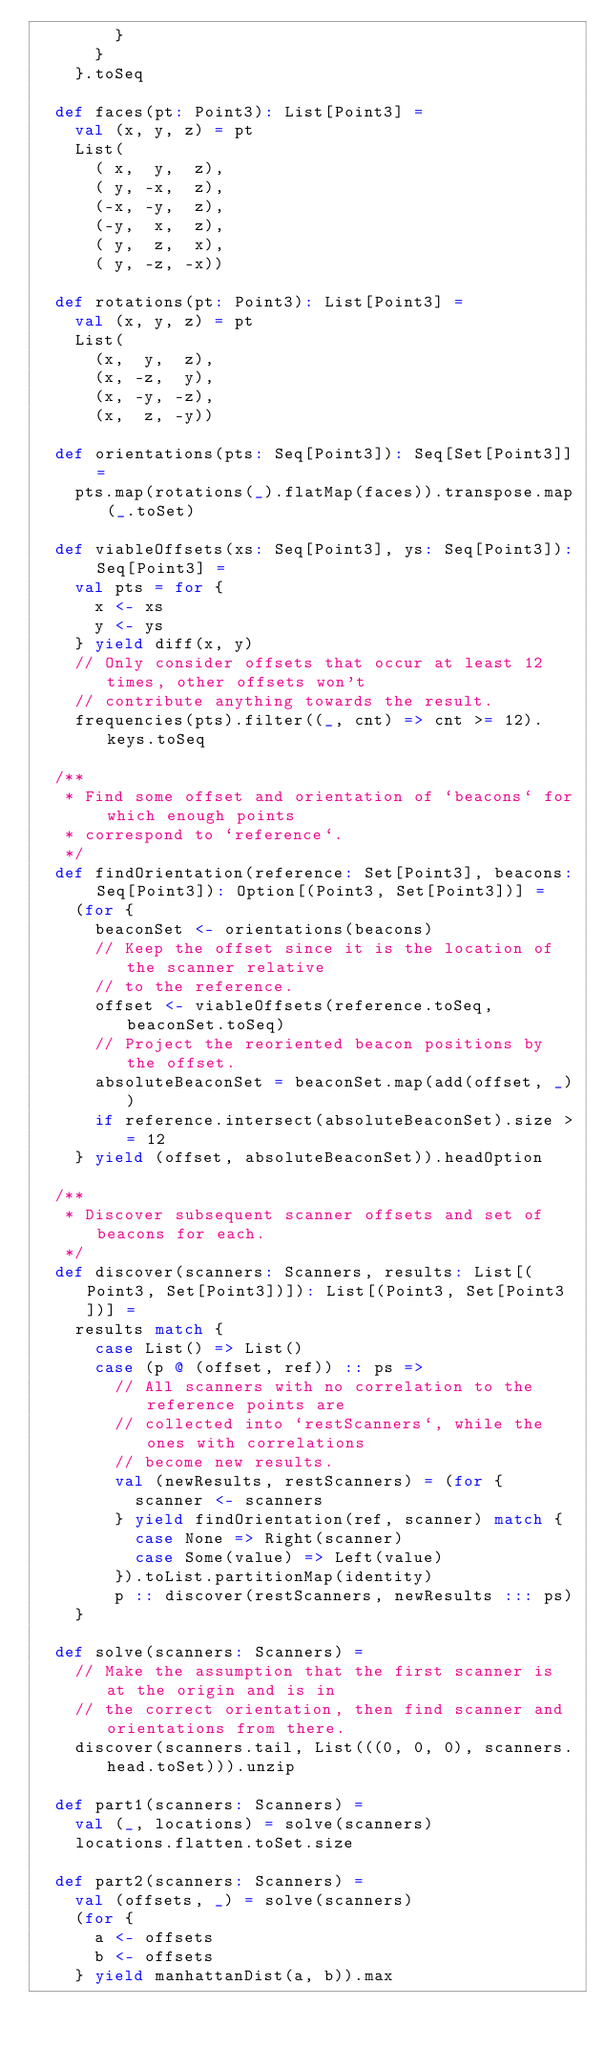<code> <loc_0><loc_0><loc_500><loc_500><_Scala_>        }
      }
    }.toSeq

  def faces(pt: Point3): List[Point3] =
    val (x, y, z) = pt
    List(
      ( x,  y,  z),
      ( y, -x,  z),
      (-x, -y,  z),
      (-y,  x,  z),
      ( y,  z,  x),
      ( y, -z, -x))

  def rotations(pt: Point3): List[Point3] =
    val (x, y, z) = pt
    List(
      (x,  y,  z),
      (x, -z,  y),
      (x, -y, -z),
      (x,  z, -y))

  def orientations(pts: Seq[Point3]): Seq[Set[Point3]] =
    pts.map(rotations(_).flatMap(faces)).transpose.map(_.toSet)

  def viableOffsets(xs: Seq[Point3], ys: Seq[Point3]): Seq[Point3] =
    val pts = for {
      x <- xs
      y <- ys
    } yield diff(x, y)
    // Only consider offsets that occur at least 12 times, other offsets won't
    // contribute anything towards the result.
    frequencies(pts).filter((_, cnt) => cnt >= 12).keys.toSeq

  /**
   * Find some offset and orientation of `beacons` for which enough points
   * correspond to `reference`.
   */
  def findOrientation(reference: Set[Point3], beacons: Seq[Point3]): Option[(Point3, Set[Point3])] =
    (for {
      beaconSet <- orientations(beacons)
      // Keep the offset since it is the location of the scanner relative
      // to the reference.
      offset <- viableOffsets(reference.toSeq, beaconSet.toSeq)
      // Project the reoriented beacon positions by the offset.
      absoluteBeaconSet = beaconSet.map(add(offset, _))
      if reference.intersect(absoluteBeaconSet).size >= 12
    } yield (offset, absoluteBeaconSet)).headOption

  /**
   * Discover subsequent scanner offsets and set of beacons for each.
   */
  def discover(scanners: Scanners, results: List[(Point3, Set[Point3])]): List[(Point3, Set[Point3])] =
    results match {
      case List() => List()
      case (p @ (offset, ref)) :: ps =>
        // All scanners with no correlation to the reference points are
        // collected into `restScanners`, while the ones with correlations
        // become new results.
        val (newResults, restScanners) = (for {
          scanner <- scanners
        } yield findOrientation(ref, scanner) match {
          case None => Right(scanner)
          case Some(value) => Left(value)
        }).toList.partitionMap(identity)
        p :: discover(restScanners, newResults ::: ps)
    }

  def solve(scanners: Scanners) =
    // Make the assumption that the first scanner is at the origin and is in
    // the correct orientation, then find scanner and orientations from there.
    discover(scanners.tail, List(((0, 0, 0), scanners.head.toSet))).unzip

  def part1(scanners: Scanners) =
    val (_, locations) = solve(scanners)
    locations.flatten.toSet.size

  def part2(scanners: Scanners) =
    val (offsets, _) = solve(scanners)
    (for {
      a <- offsets
      b <- offsets
    } yield manhattanDist(a, b)).max
</code> 